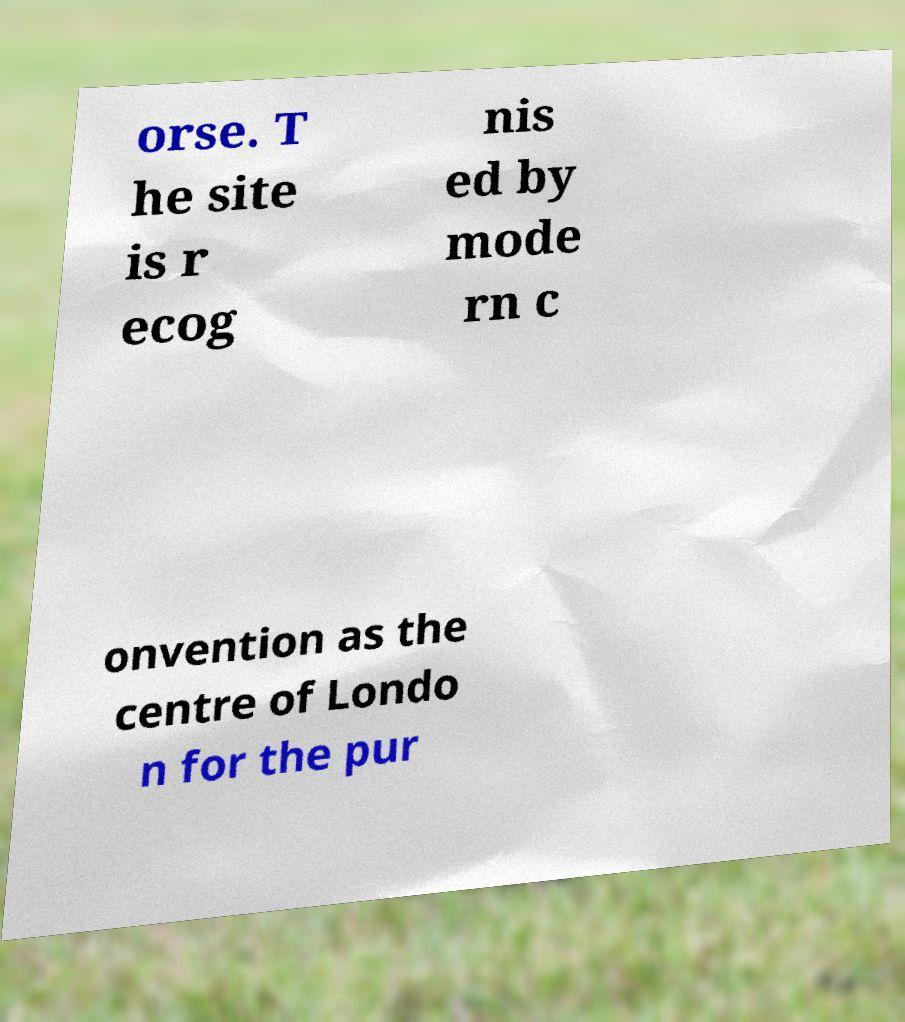There's text embedded in this image that I need extracted. Can you transcribe it verbatim? orse. T he site is r ecog nis ed by mode rn c onvention as the centre of Londo n for the pur 